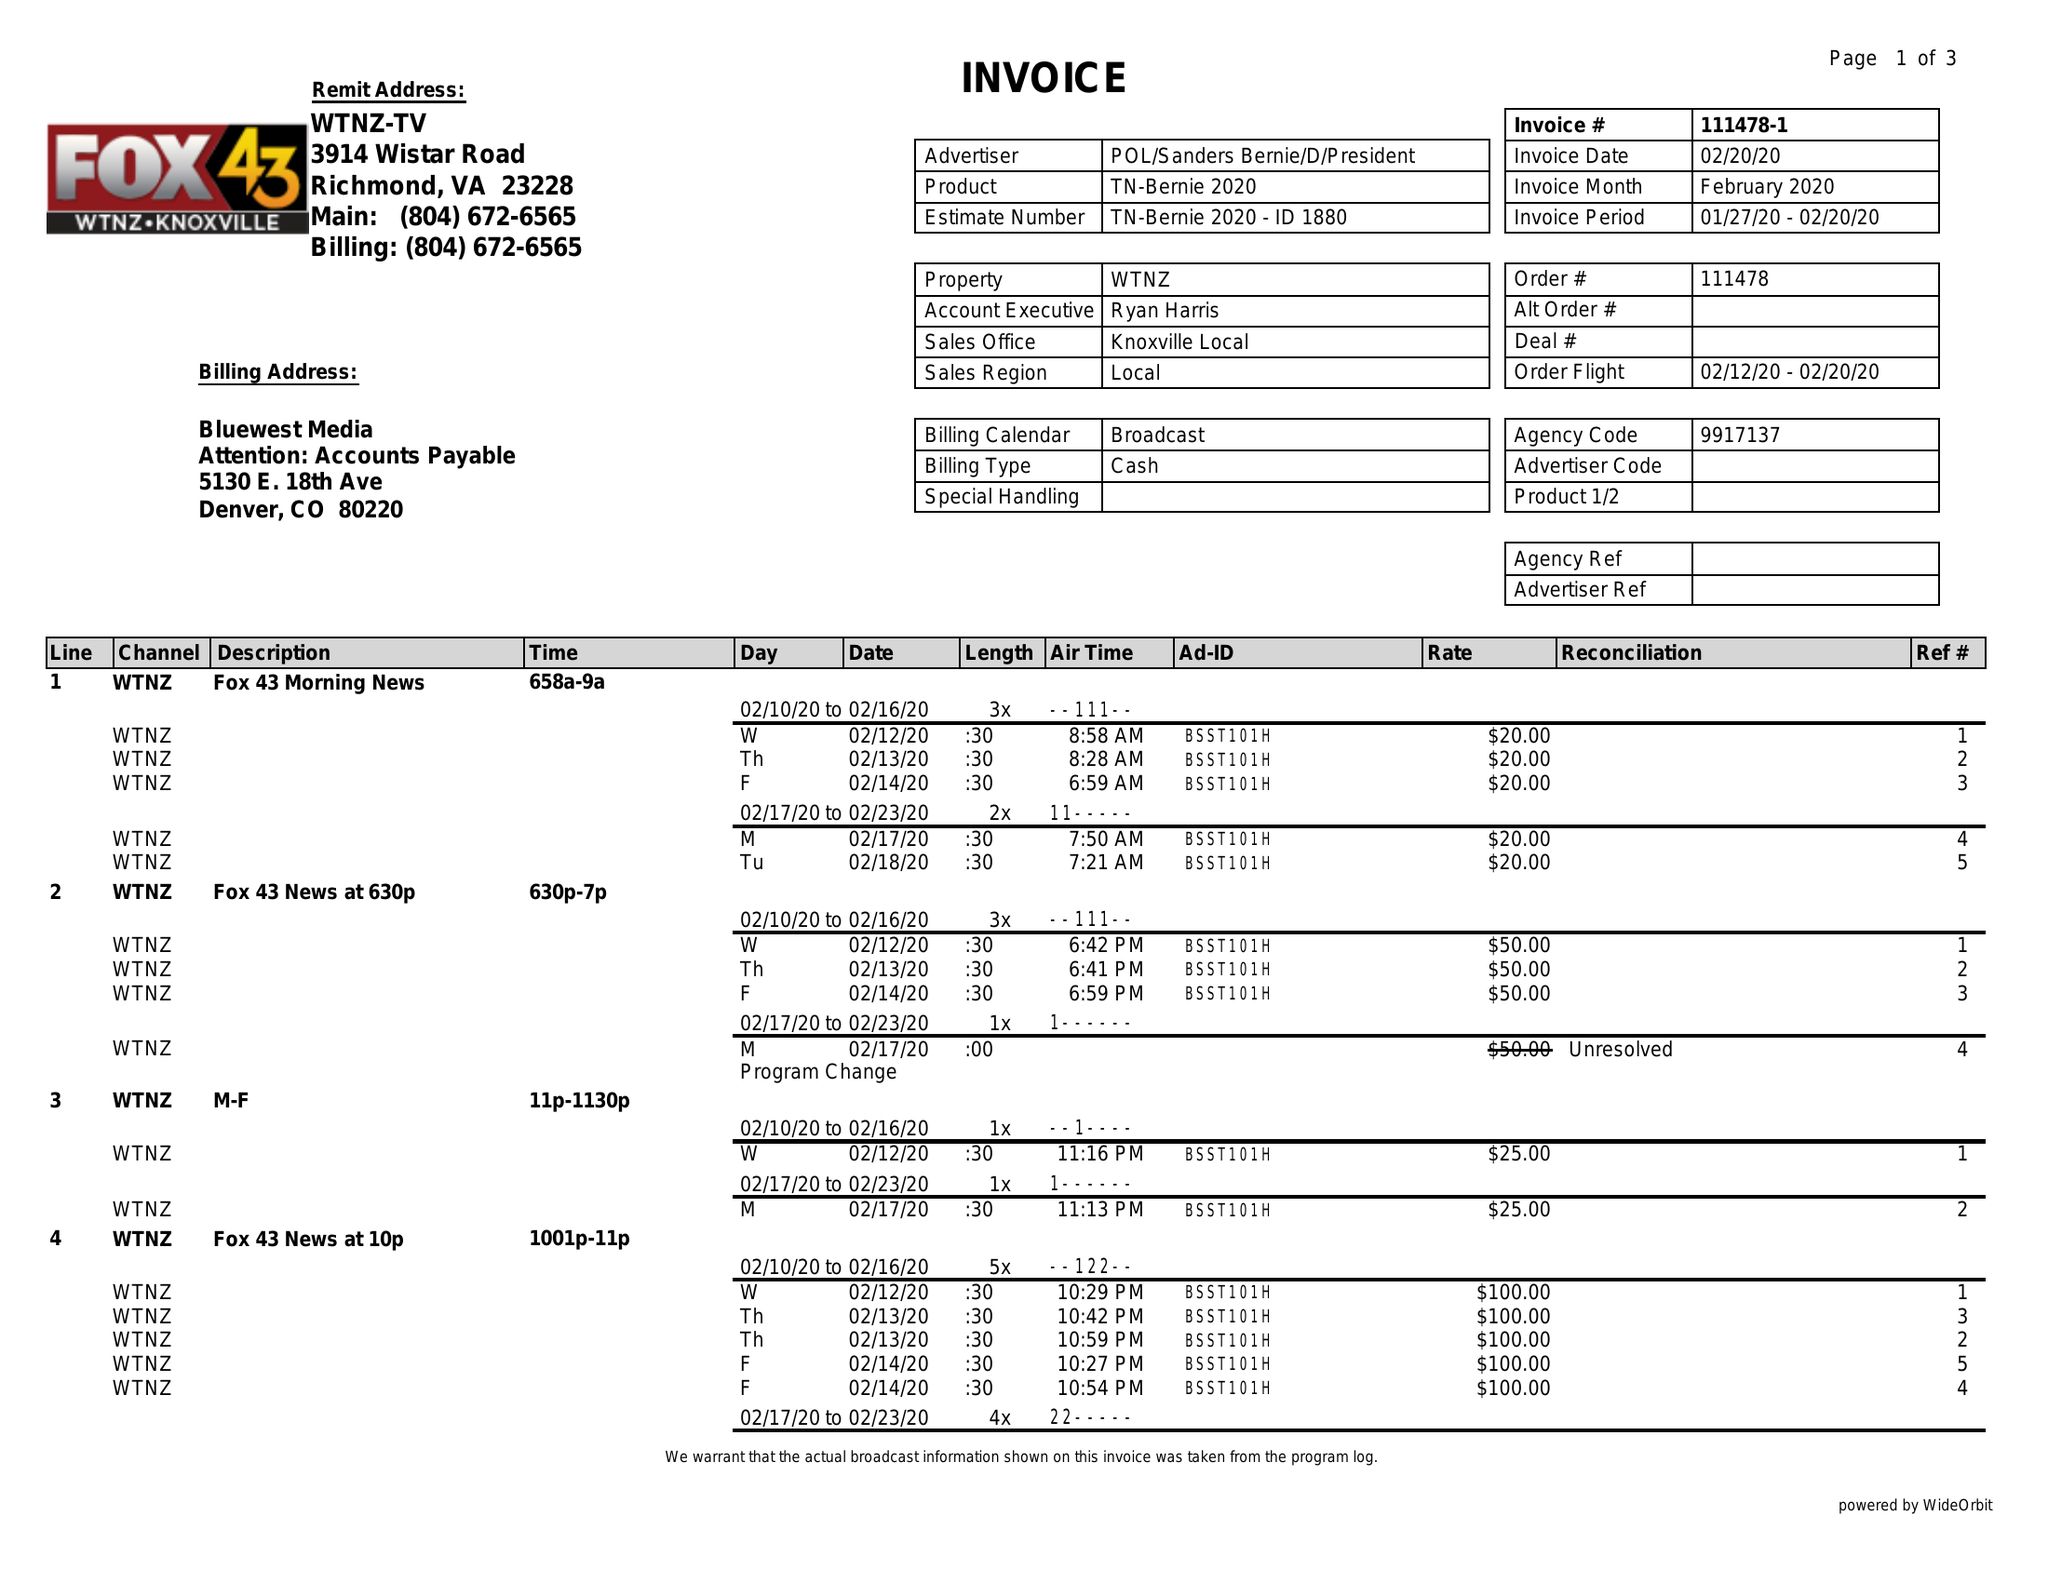What is the value for the advertiser?
Answer the question using a single word or phrase. POL/SANDERSBERNIE/D/PRESIDENT 